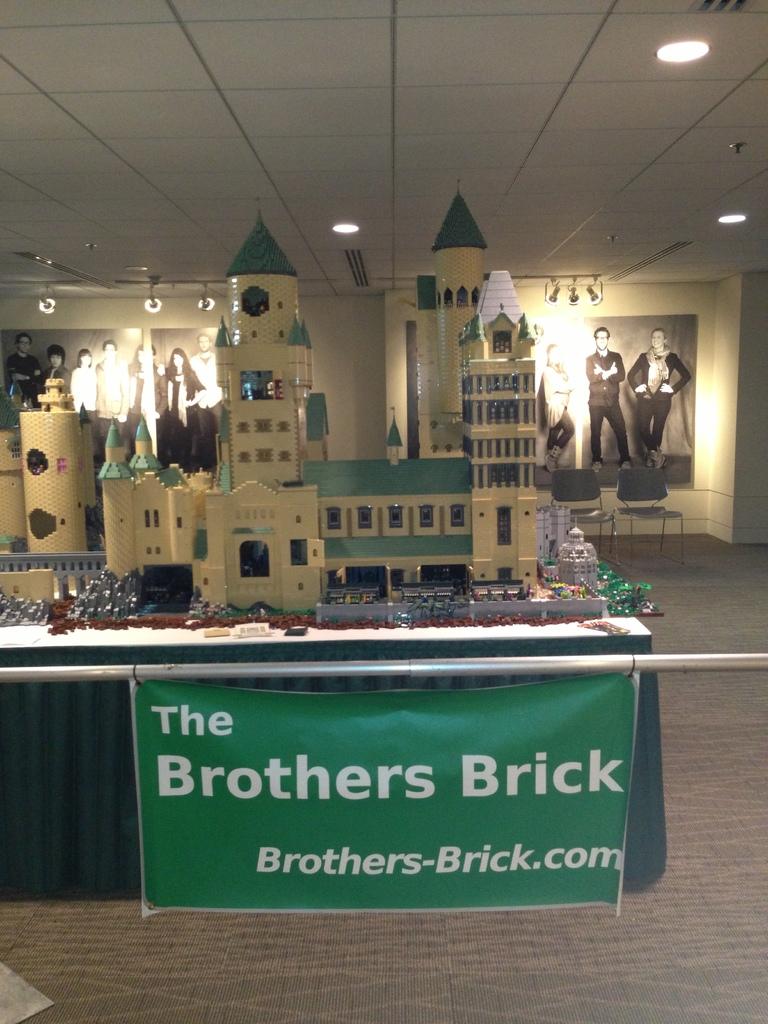What website is listed on the banner?
Make the answer very short. Brothers-brick.com. 